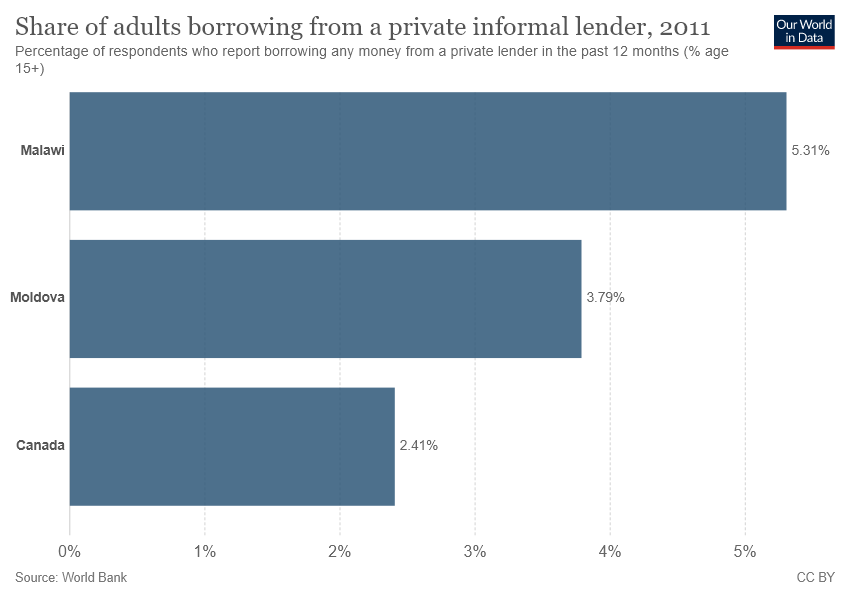Identify some key points in this picture. The value of the smallest bar is 0.0241. The smallest bar value is greater than the difference of the largest two bar values. 